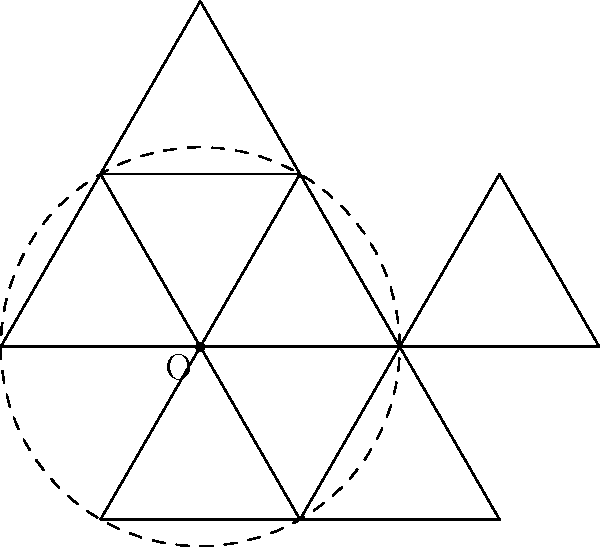In designing a game landscape with repeating patterns, you want to create a hexagonal tessellation using equilateral triangles. Given the diagram showing a central equilateral triangle surrounded by five rotated copies, what is the angle of rotation between each successive triangle around the center point O? To determine the angle of rotation between each successive triangle, let's follow these steps:

1) First, recall that a hexagon has 6 equal sides and 6 equal angles.

2) The internal angle of a regular hexagon is calculated using the formula:
   $$(n-2) \times 180^\circ / n$$
   where $n$ is the number of sides.
   
3) For a hexagon, this gives us:
   $$(6-2) \times 180^\circ / 6 = 120^\circ$$

4) This means that each vertex of the hexagon is at an angle of $120^\circ$ from the center to the next vertex.

5) However, we're asked about the rotation between each triangle, not each vertex of the hexagon.

6) Notice that each triangle spans two vertices of the hexagon.

7) Therefore, the angle of rotation between each triangle is half of the angle between vertices:
   $$120^\circ / 2 = 60^\circ$$

8) We can verify this by noting that to make a full rotation ($360^\circ$), we need 6 rotations of $60^\circ$ each:
   $$6 \times 60^\circ = 360^\circ$$

Thus, the angle of rotation between each successive triangle is $60^\circ$.
Answer: $60^\circ$ 